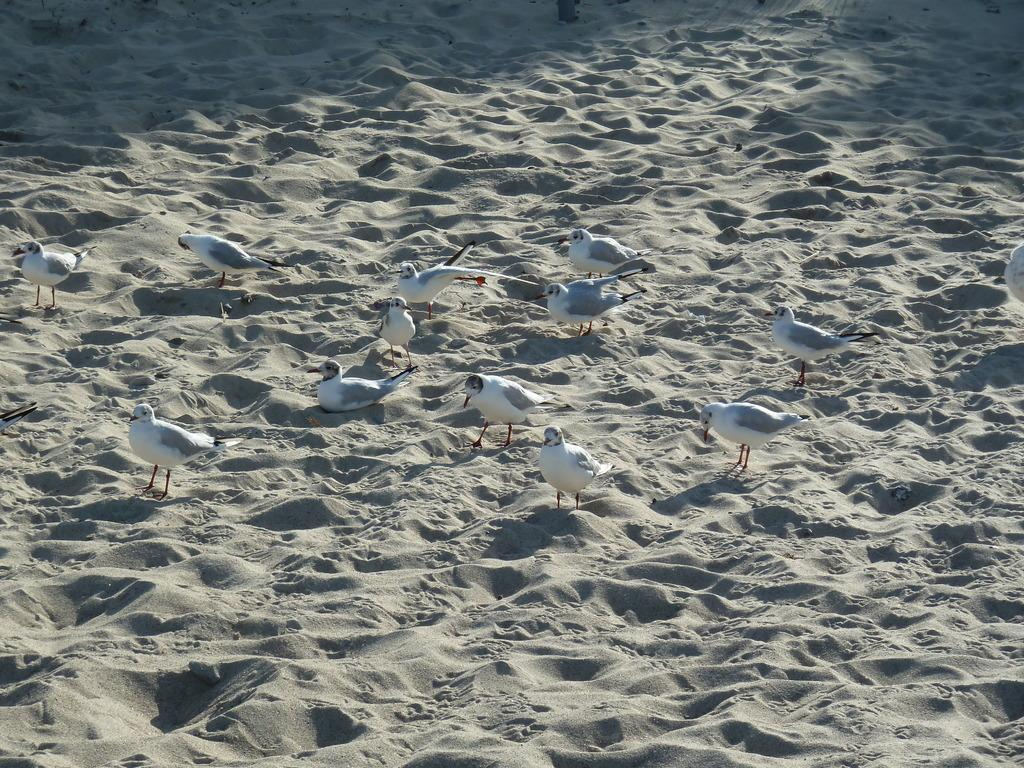What type of animals can be seen in the image? There is a flock of birds in the image. What are the birds doing in the image? The birds are standing. What type of terrain is visible in the image? There is sand visible in the image. Where is the faucet located in the image? There is no faucet present in the image. What type of record is being played by the birds in the image? There is no record or music being played by the birds in the image. 